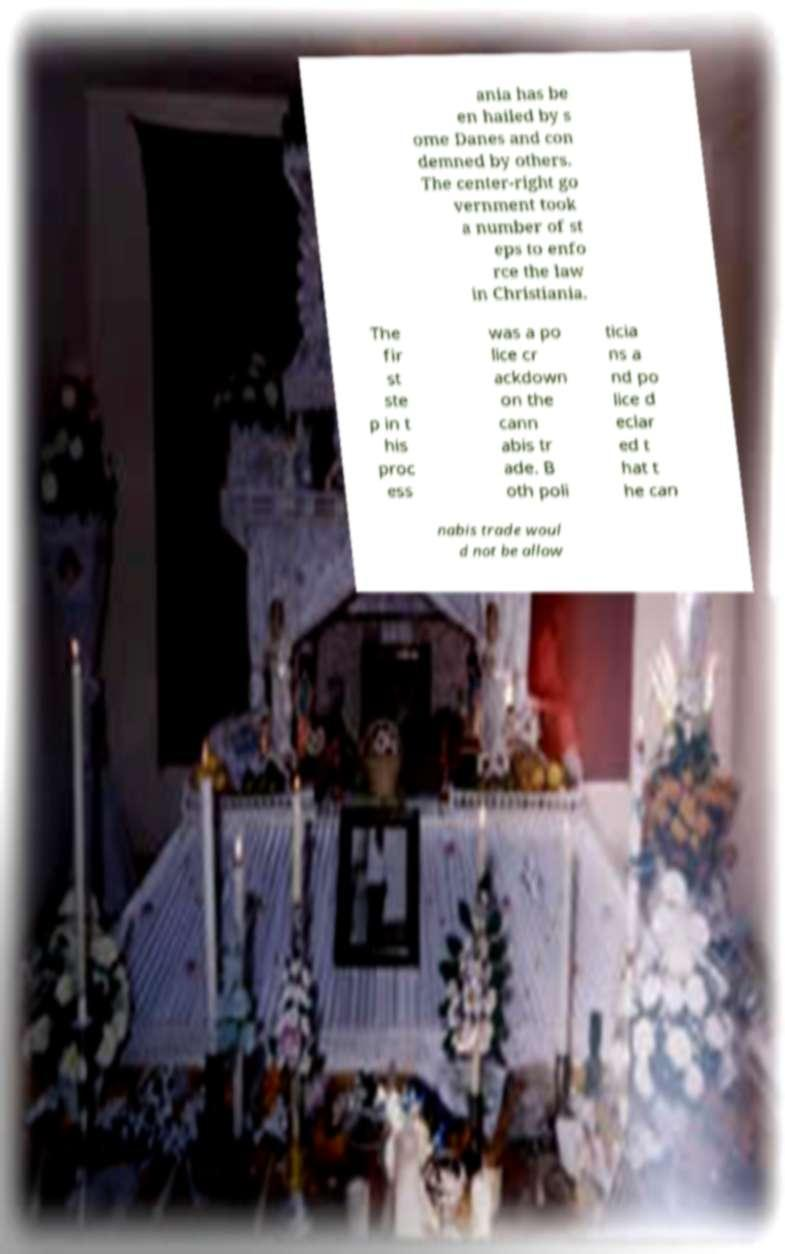Can you read and provide the text displayed in the image?This photo seems to have some interesting text. Can you extract and type it out for me? ania has be en hailed by s ome Danes and con demned by others. The center-right go vernment took a number of st eps to enfo rce the law in Christiania. The fir st ste p in t his proc ess was a po lice cr ackdown on the cann abis tr ade. B oth poli ticia ns a nd po lice d eclar ed t hat t he can nabis trade woul d not be allow 